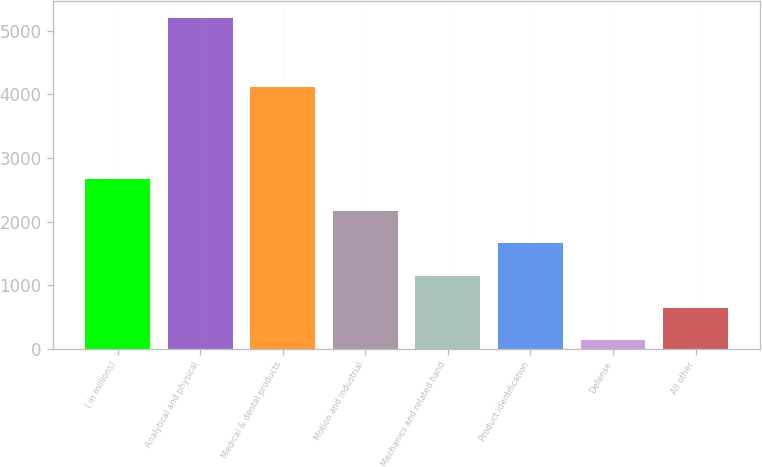Convert chart. <chart><loc_0><loc_0><loc_500><loc_500><bar_chart><fcel>( in millions)<fcel>Analytical and physical<fcel>Medical & dental products<fcel>Motion and industrial<fcel>Mechanics and related hand<fcel>Product identification<fcel>Defense<fcel>All other<nl><fcel>2671.3<fcel>5206<fcel>4122.9<fcel>2164.36<fcel>1150.48<fcel>1657.42<fcel>136.6<fcel>643.54<nl></chart> 